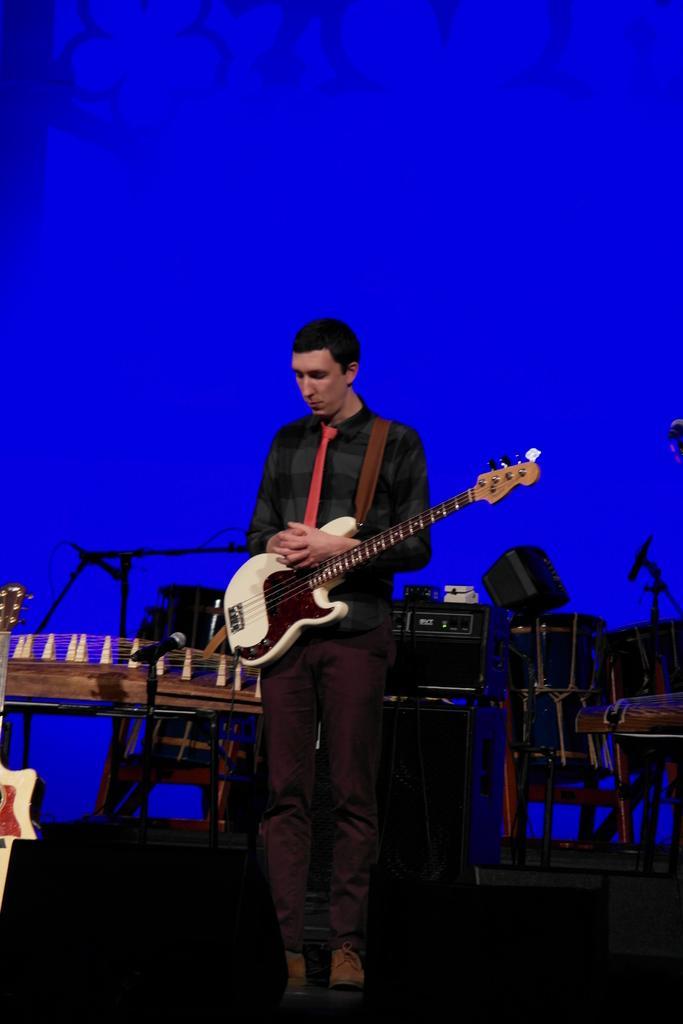Can you describe this image briefly? The picture is taken in a musical concert where a guy is holding a guitar with both his hands , in the background we observe many musical instruments like table and black sound system boxes. The background is blue in color. 